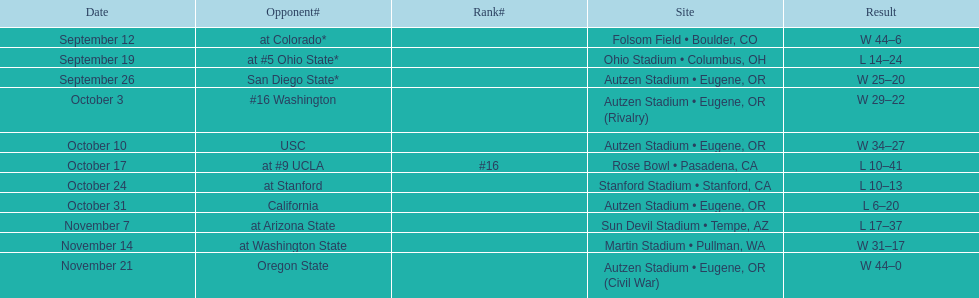How many games did the team win while not at home? 2. 